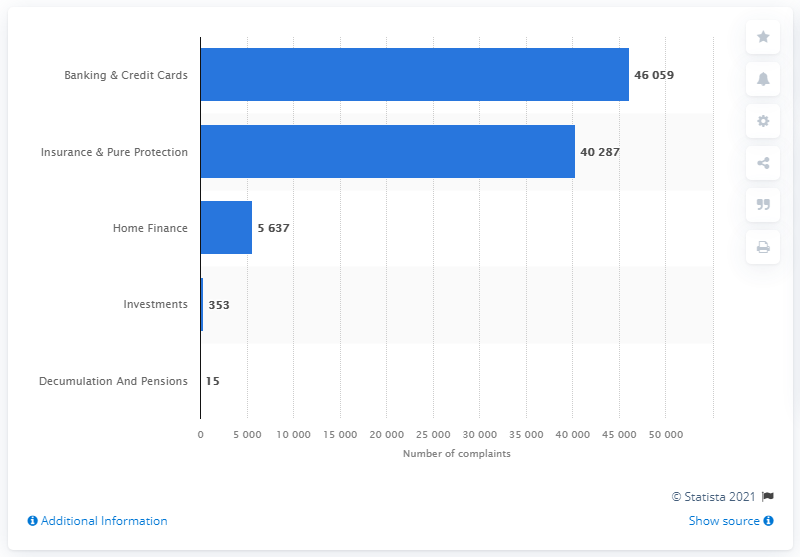Draw attention to some important aspects in this diagram. In the first half of 2020, a total of 40,287 complaints were filed against the Nationwide Building Society. 